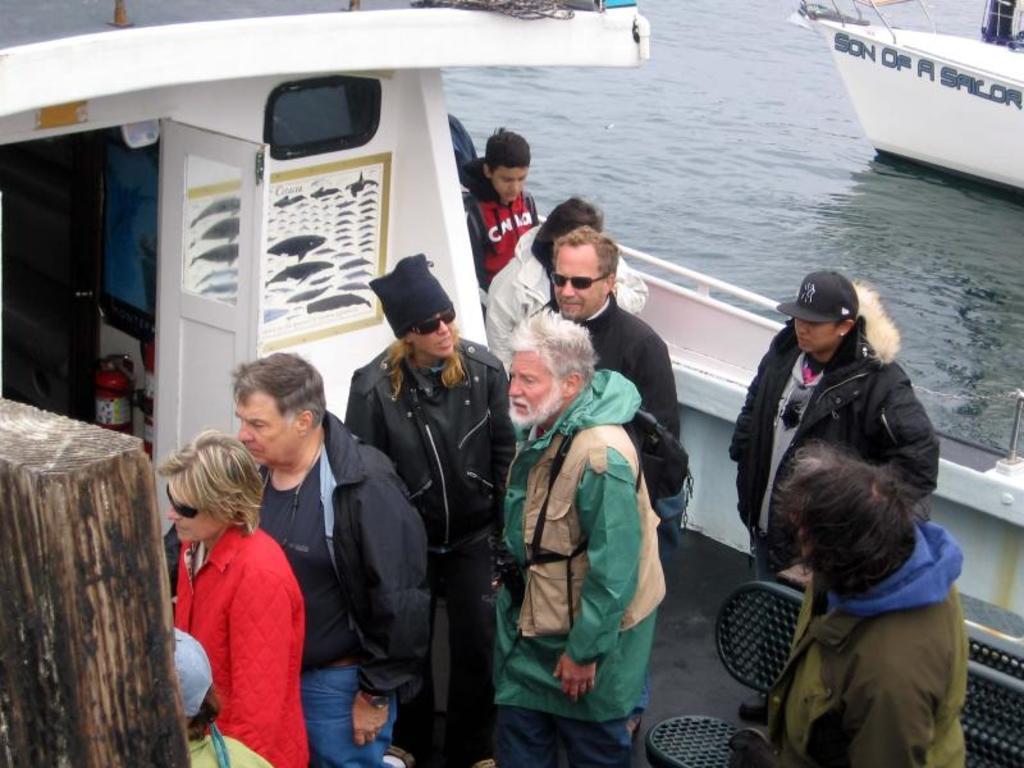Can you describe this image briefly? In this picture I can see there are a few people standing on the boat and there is a poster of fishes and there is a black bench at right side and there is a wooden plank at left. There is another boat sailing on water at the right side. 